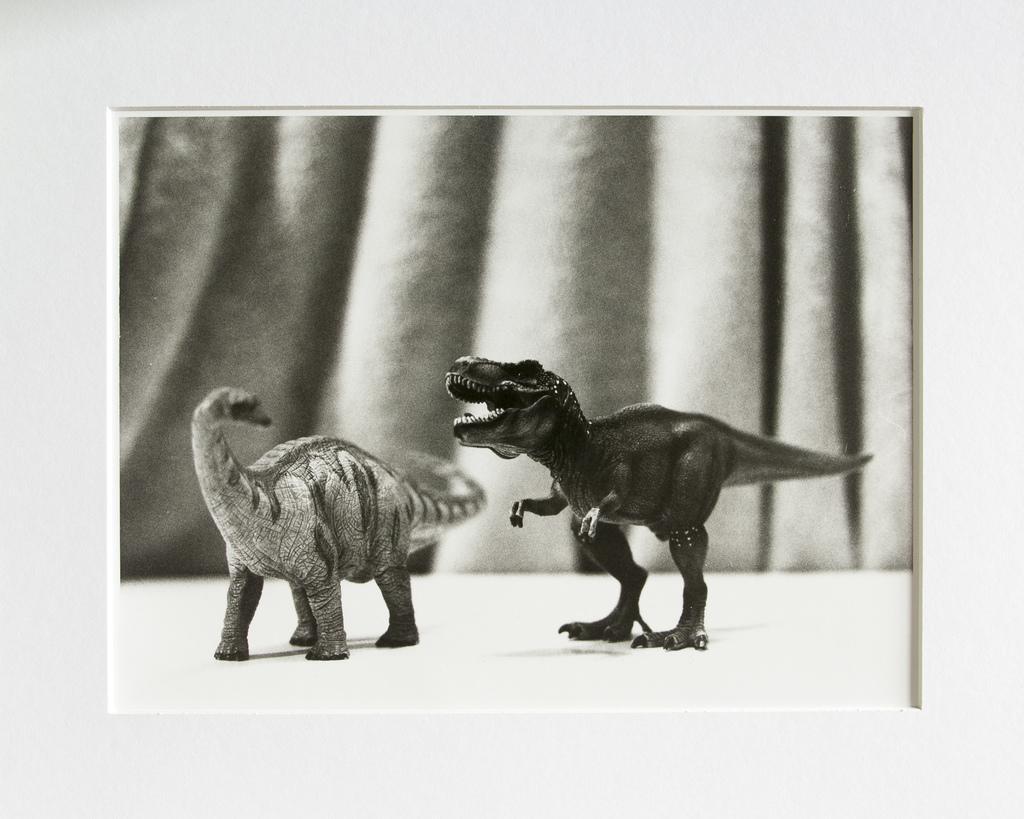Describe this image in one or two sentences. In this picture we can see two toys in the front, in the background there is a curtain, we can see a blurry background, it looks like a photo frame. 